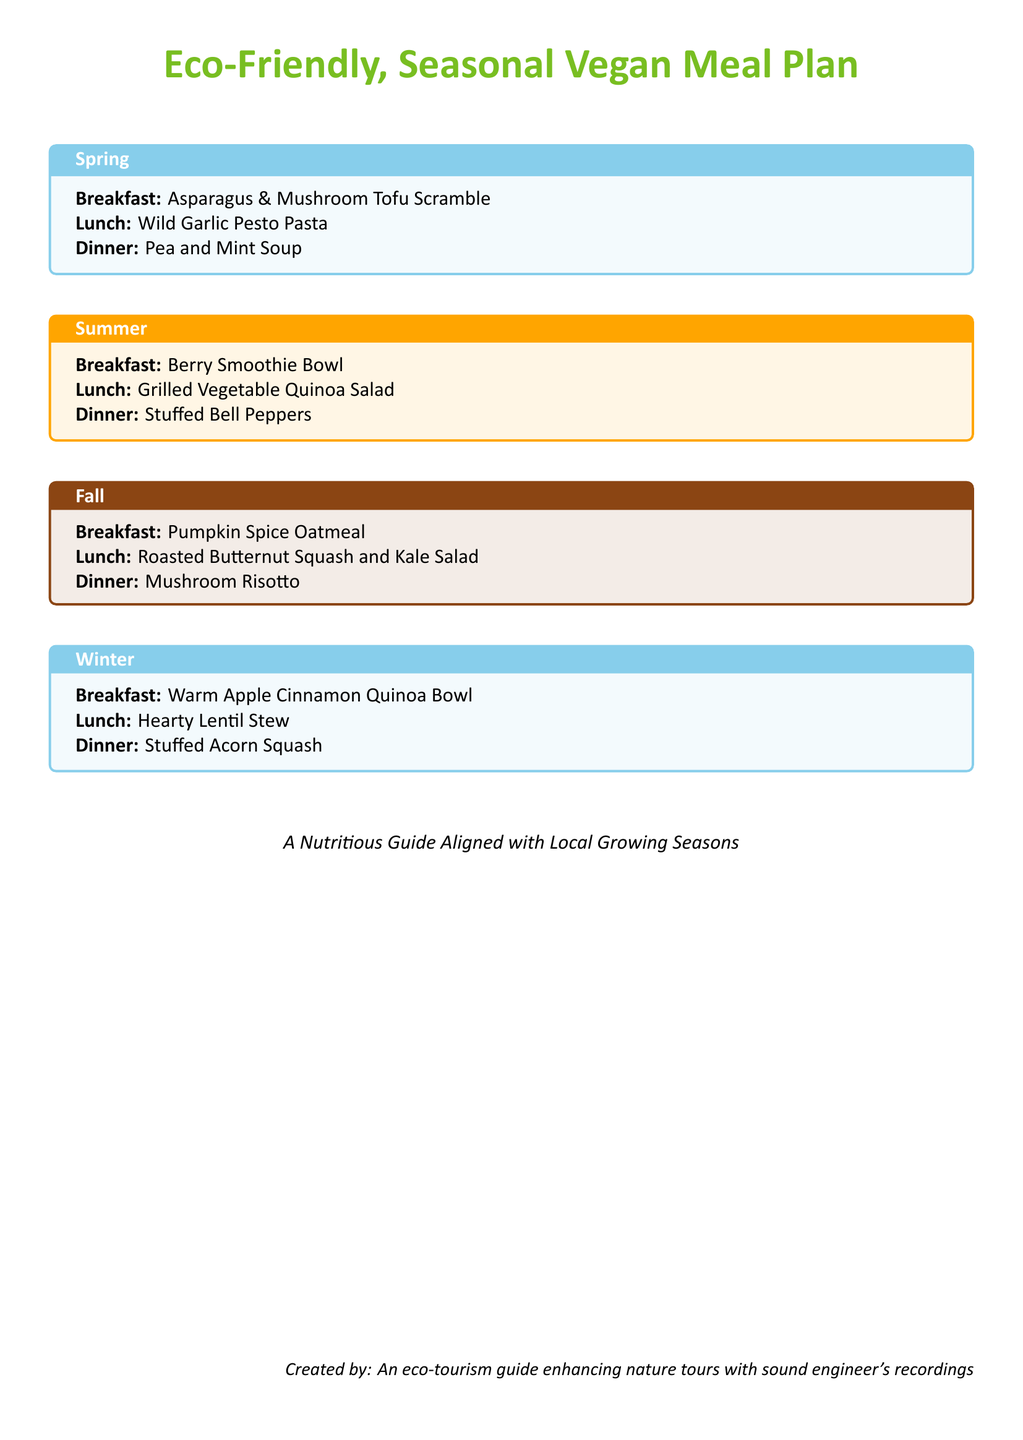What is the breakfast option for Spring? The breakfast option for Spring is specified in the document as the Asparagus & Mushroom Tofu Scramble.
Answer: Asparagus & Mushroom Tofu Scramble What color is used for the title background in Summer? The document indicates that the background color for the title in Summer is sunnyorange!10.
Answer: sunnyorange How many meal options are there for each season? The document describes three meal options for each season: breakfast, lunch, and dinner.
Answer: three What is the dinner option for Winter? The dinner option for Winter, according to the document, is Stuffed Acorn Squash.
Answer: Stuffed Acorn Squash What type of cuisine does the meal plan focus on? The meal plan explicitly highlights that it is a Vegan Meal Plan, focusing on plant-based recipes.
Answer: Vegan Meal Plan Which season features Pumpkin Spice Oatmeal? The document identifies that Pumpkin Spice Oatmeal is the breakfast option in Fall.
Answer: Fall 